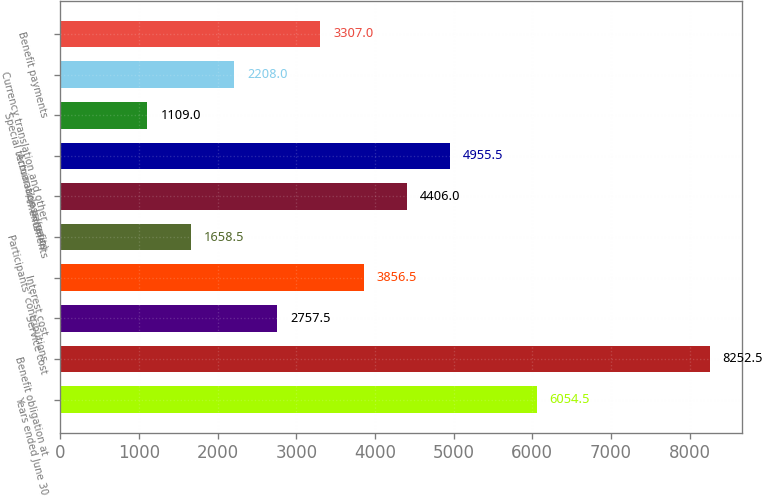Convert chart to OTSL. <chart><loc_0><loc_0><loc_500><loc_500><bar_chart><fcel>Years ended June 30<fcel>Benefit obligation at<fcel>Service cost<fcel>Interest cost<fcel>Participants' contributions<fcel>Amendments<fcel>Actuarial loss/(gain)<fcel>Special termination benefits<fcel>Currency translation and other<fcel>Benefit payments<nl><fcel>6054.5<fcel>8252.5<fcel>2757.5<fcel>3856.5<fcel>1658.5<fcel>4406<fcel>4955.5<fcel>1109<fcel>2208<fcel>3307<nl></chart> 